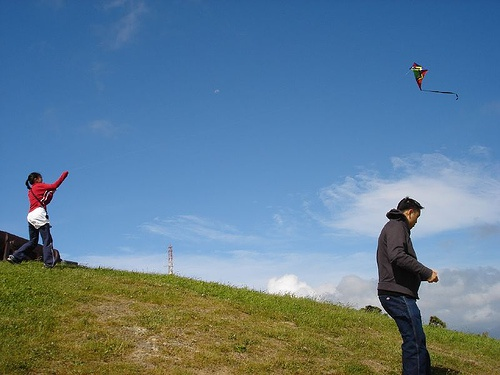Describe the objects in this image and their specific colors. I can see people in blue, black, and gray tones, people in blue, black, white, and brown tones, kite in blue, black, gray, and navy tones, and handbag in blue, maroon, black, and brown tones in this image. 